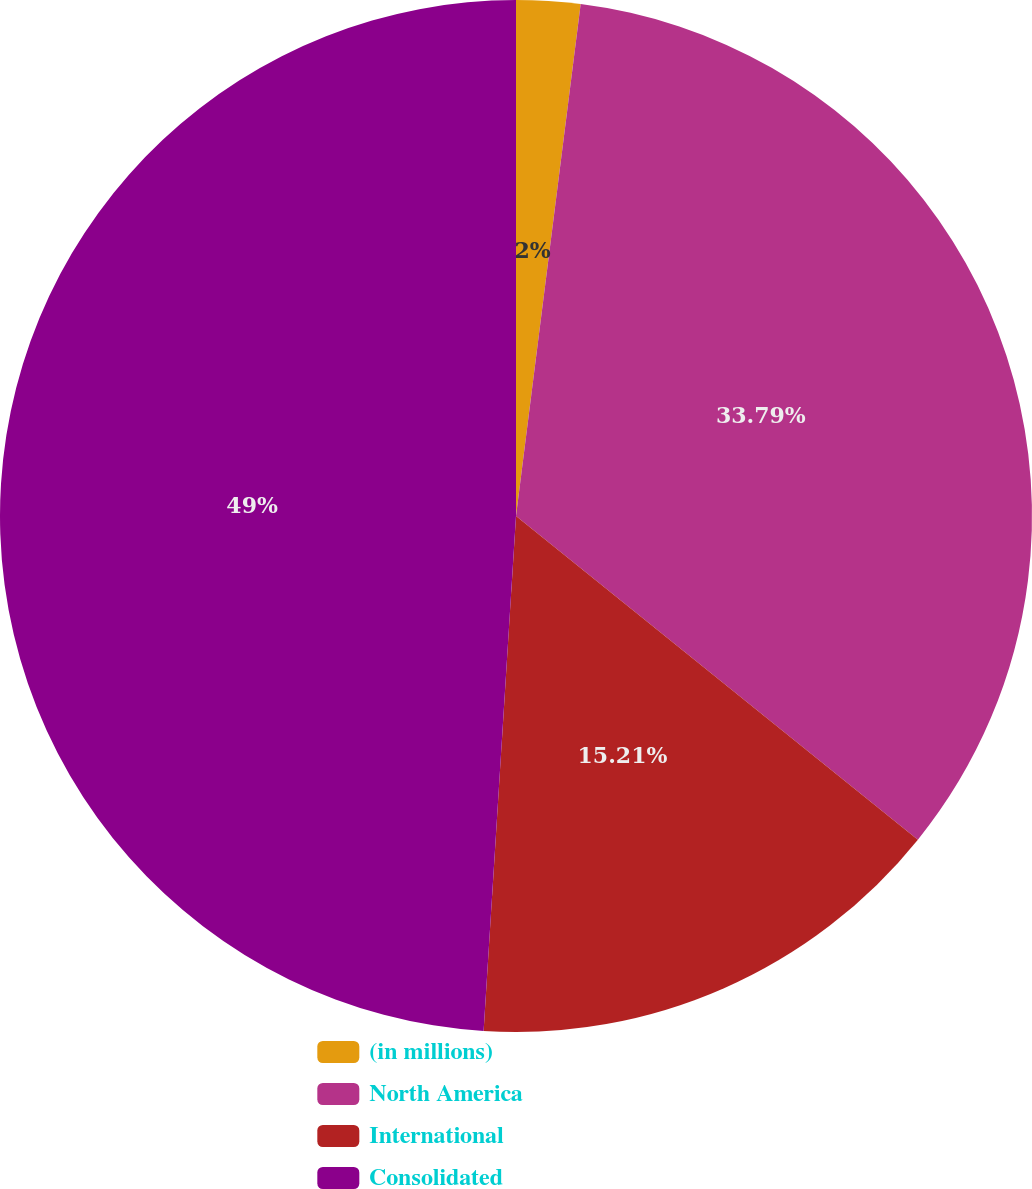<chart> <loc_0><loc_0><loc_500><loc_500><pie_chart><fcel>(in millions)<fcel>North America<fcel>International<fcel>Consolidated<nl><fcel>2.0%<fcel>33.79%<fcel>15.21%<fcel>49.0%<nl></chart> 